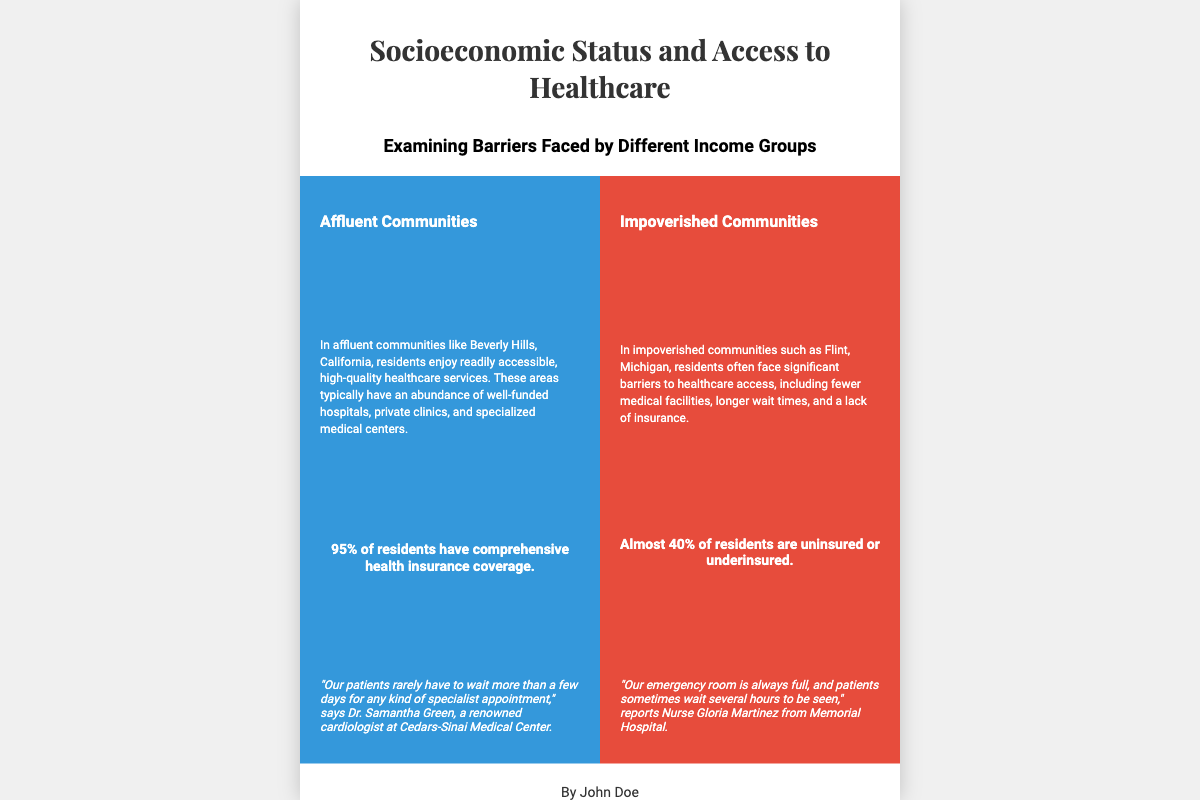What is the title of the book? The title is prominently displayed at the top of the book cover.
Answer: Socioeconomic Status and Access to Healthcare Who is the author of the book? The author's name is located at the bottom of the book cover.
Answer: John Doe What percentage of affluent residents have comprehensive health insurance coverage? This statistic is provided in the affluent section of the document.
Answer: 95% What is a major issue faced by impoverished communities regarding healthcare? The document states several barriers faced by impoverished communities, highlighting a specific issue.
Answer: Lack of insurance Which community is used as an example of an affluent area? The affluent section cites a specific affluent community for illustration.
Answer: Beverly Hills What is the average wait time for specialist appointments in affluent communities? This information is based on a quote provided by a professional within the affluent community.
Answer: A few days What is the percentage of uninsured or underinsured residents in impoverished communities? The document specifies a statistic related to health insurance in impoverished communities.
Answer: Almost 40% What type of design is utilized in the book cover? The structure of the cover indicates a particular visual design style.
Answer: Split-page design What color represents the affluent community in the book cover? The background color for this section is specifically chosen in the design.
Answer: Blue 